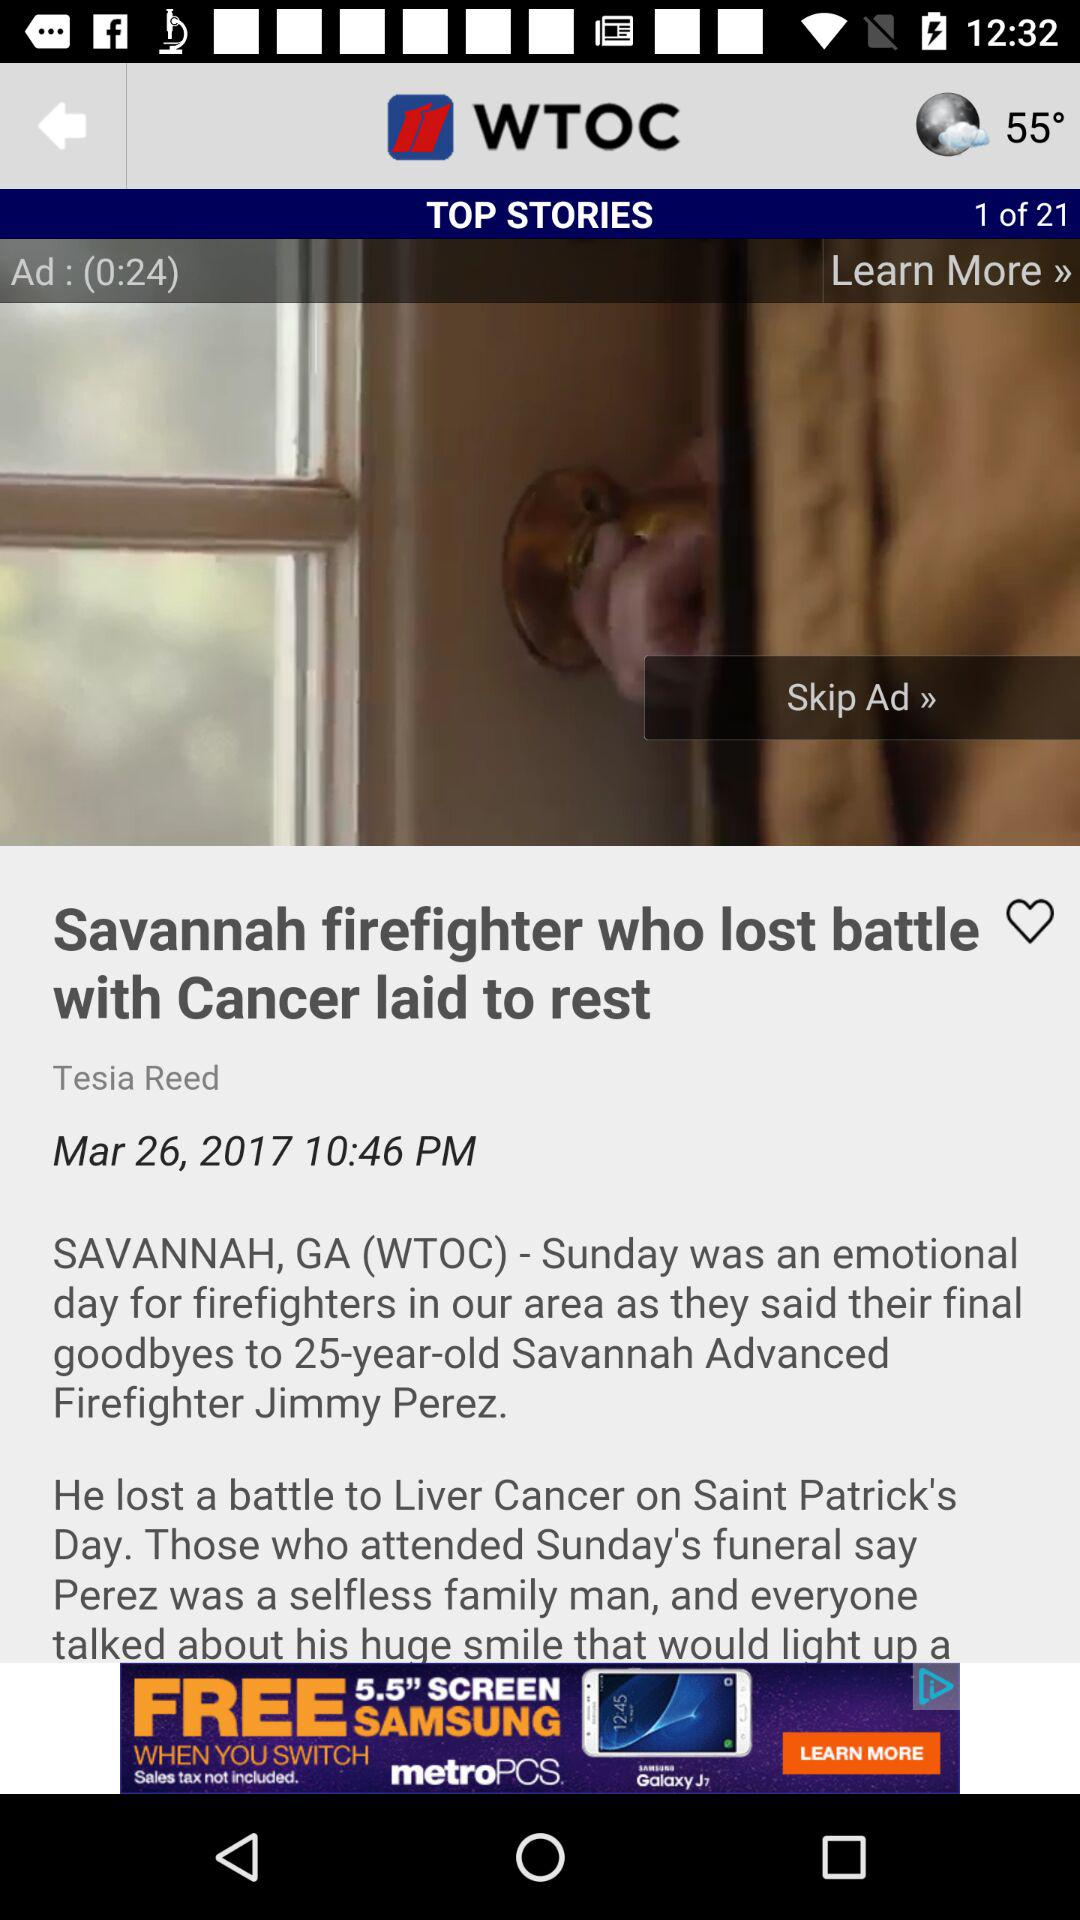Will it be cloudy tomorrow?
When the provided information is insufficient, respond with <no answer>. <no answer> 